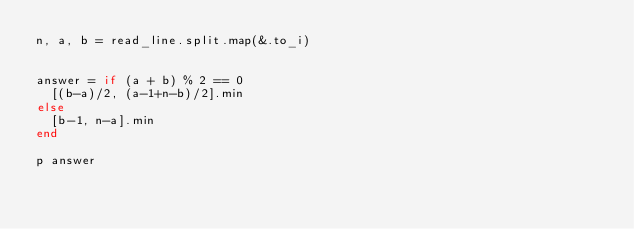Convert code to text. <code><loc_0><loc_0><loc_500><loc_500><_Crystal_>n, a, b = read_line.split.map(&.to_i)


answer = if (a + b) % 2 == 0
  [(b-a)/2, (a-1+n-b)/2].min
else
  [b-1, n-a].min
end

p answer
</code> 